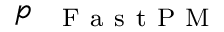<formula> <loc_0><loc_0><loc_500><loc_500>p _ { { F a s t P M } }</formula> 